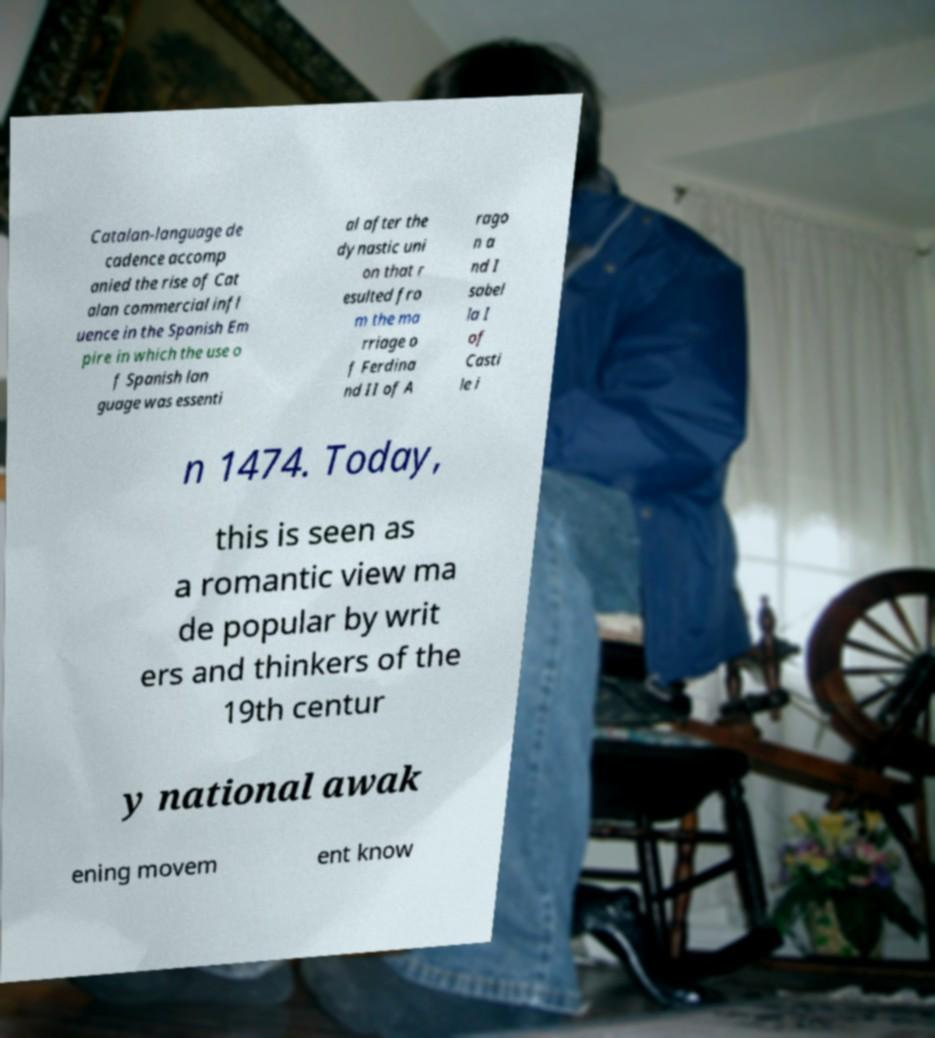Please identify and transcribe the text found in this image. Catalan-language de cadence accomp anied the rise of Cat alan commercial infl uence in the Spanish Em pire in which the use o f Spanish lan guage was essenti al after the dynastic uni on that r esulted fro m the ma rriage o f Ferdina nd II of A rago n a nd I sabel la I of Casti le i n 1474. Today, this is seen as a romantic view ma de popular by writ ers and thinkers of the 19th centur y national awak ening movem ent know 